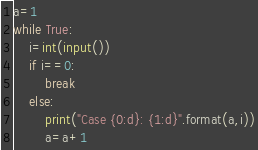<code> <loc_0><loc_0><loc_500><loc_500><_Python_>a=1
while True:
    i=int(input())
    if i==0:
        break
    else:
        print("Case {0:d}: {1:d}".format(a,i))
        a=a+1</code> 